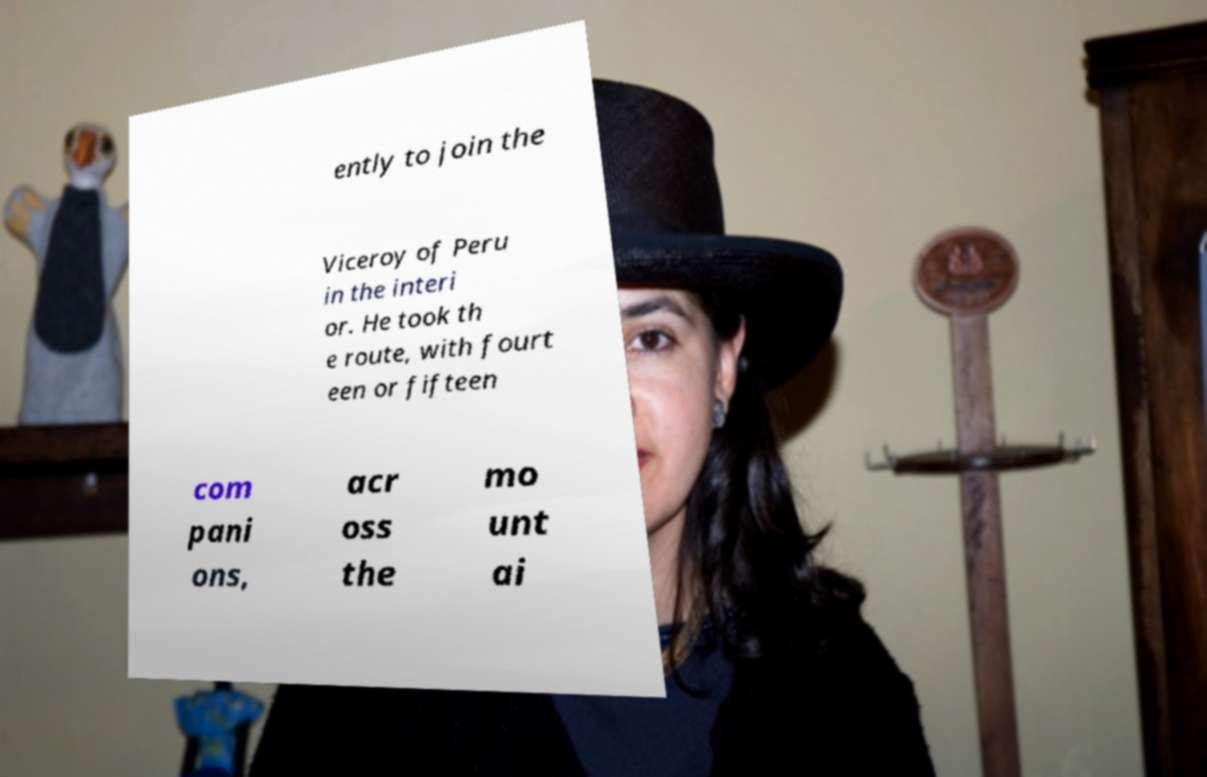I need the written content from this picture converted into text. Can you do that? ently to join the Viceroy of Peru in the interi or. He took th e route, with fourt een or fifteen com pani ons, acr oss the mo unt ai 